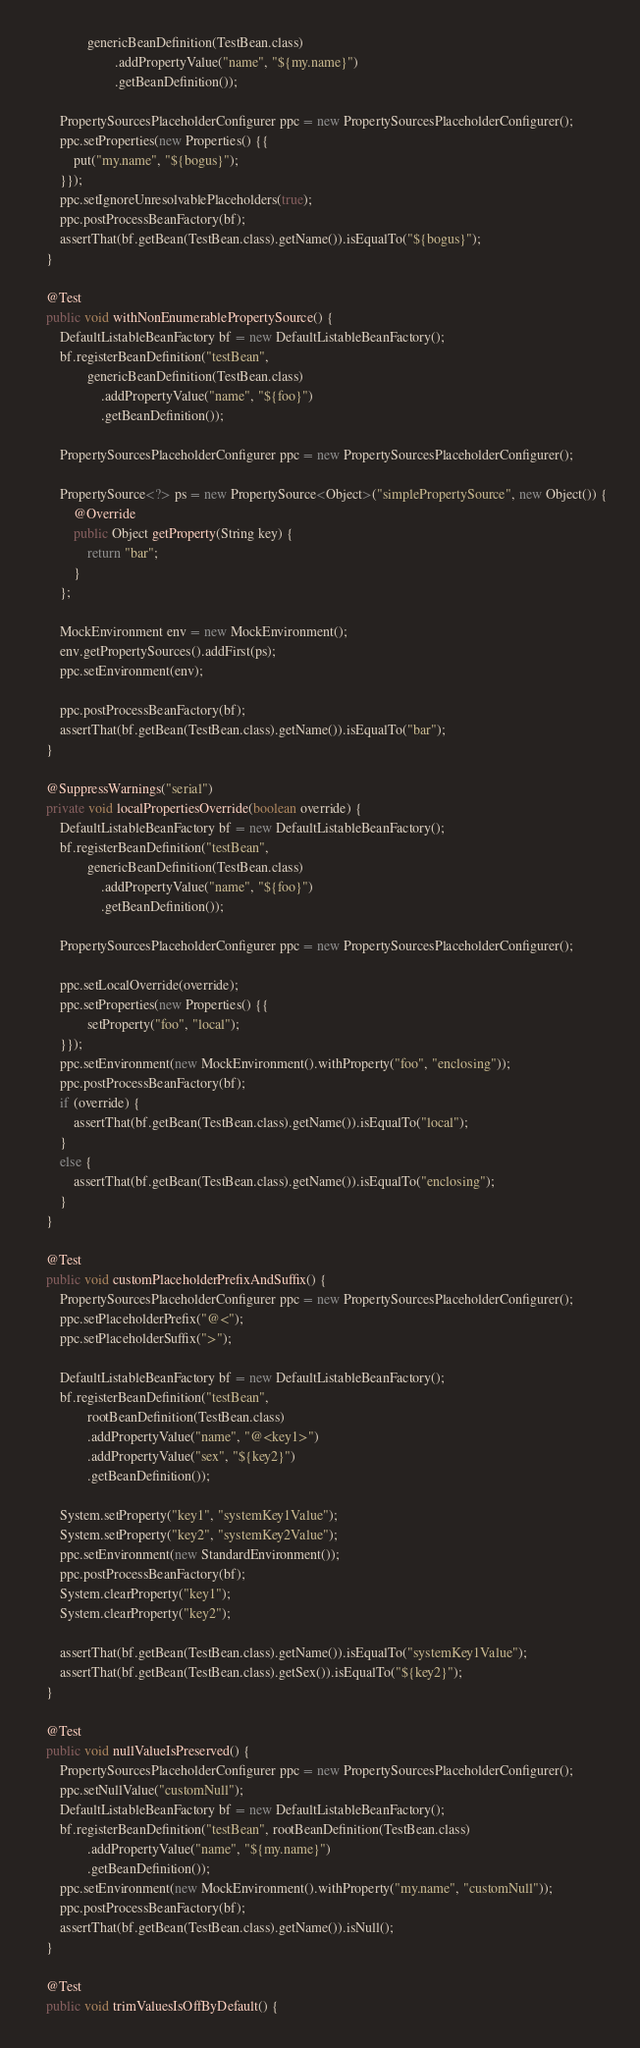Convert code to text. <code><loc_0><loc_0><loc_500><loc_500><_Java_>				genericBeanDefinition(TestBean.class)
						.addPropertyValue("name", "${my.name}")
						.getBeanDefinition());

		PropertySourcesPlaceholderConfigurer ppc = new PropertySourcesPlaceholderConfigurer();
		ppc.setProperties(new Properties() {{
			put("my.name", "${bogus}");
		}});
		ppc.setIgnoreUnresolvablePlaceholders(true);
		ppc.postProcessBeanFactory(bf);
		assertThat(bf.getBean(TestBean.class).getName()).isEqualTo("${bogus}");
	}

	@Test
	public void withNonEnumerablePropertySource() {
		DefaultListableBeanFactory bf = new DefaultListableBeanFactory();
		bf.registerBeanDefinition("testBean",
				genericBeanDefinition(TestBean.class)
					.addPropertyValue("name", "${foo}")
					.getBeanDefinition());

		PropertySourcesPlaceholderConfigurer ppc = new PropertySourcesPlaceholderConfigurer();

		PropertySource<?> ps = new PropertySource<Object>("simplePropertySource", new Object()) {
			@Override
			public Object getProperty(String key) {
				return "bar";
			}
		};

		MockEnvironment env = new MockEnvironment();
		env.getPropertySources().addFirst(ps);
		ppc.setEnvironment(env);

		ppc.postProcessBeanFactory(bf);
		assertThat(bf.getBean(TestBean.class).getName()).isEqualTo("bar");
	}

	@SuppressWarnings("serial")
	private void localPropertiesOverride(boolean override) {
		DefaultListableBeanFactory bf = new DefaultListableBeanFactory();
		bf.registerBeanDefinition("testBean",
				genericBeanDefinition(TestBean.class)
					.addPropertyValue("name", "${foo}")
					.getBeanDefinition());

		PropertySourcesPlaceholderConfigurer ppc = new PropertySourcesPlaceholderConfigurer();

		ppc.setLocalOverride(override);
		ppc.setProperties(new Properties() {{
				setProperty("foo", "local");
		}});
		ppc.setEnvironment(new MockEnvironment().withProperty("foo", "enclosing"));
		ppc.postProcessBeanFactory(bf);
		if (override) {
			assertThat(bf.getBean(TestBean.class).getName()).isEqualTo("local");
		}
		else {
			assertThat(bf.getBean(TestBean.class).getName()).isEqualTo("enclosing");
		}
	}

	@Test
	public void customPlaceholderPrefixAndSuffix() {
		PropertySourcesPlaceholderConfigurer ppc = new PropertySourcesPlaceholderConfigurer();
		ppc.setPlaceholderPrefix("@<");
		ppc.setPlaceholderSuffix(">");

		DefaultListableBeanFactory bf = new DefaultListableBeanFactory();
		bf.registerBeanDefinition("testBean",
				rootBeanDefinition(TestBean.class)
				.addPropertyValue("name", "@<key1>")
				.addPropertyValue("sex", "${key2}")
				.getBeanDefinition());

		System.setProperty("key1", "systemKey1Value");
		System.setProperty("key2", "systemKey2Value");
		ppc.setEnvironment(new StandardEnvironment());
		ppc.postProcessBeanFactory(bf);
		System.clearProperty("key1");
		System.clearProperty("key2");

		assertThat(bf.getBean(TestBean.class).getName()).isEqualTo("systemKey1Value");
		assertThat(bf.getBean(TestBean.class).getSex()).isEqualTo("${key2}");
	}

	@Test
	public void nullValueIsPreserved() {
		PropertySourcesPlaceholderConfigurer ppc = new PropertySourcesPlaceholderConfigurer();
		ppc.setNullValue("customNull");
		DefaultListableBeanFactory bf = new DefaultListableBeanFactory();
		bf.registerBeanDefinition("testBean", rootBeanDefinition(TestBean.class)
				.addPropertyValue("name", "${my.name}")
				.getBeanDefinition());
		ppc.setEnvironment(new MockEnvironment().withProperty("my.name", "customNull"));
		ppc.postProcessBeanFactory(bf);
		assertThat(bf.getBean(TestBean.class).getName()).isNull();
	}

	@Test
	public void trimValuesIsOffByDefault() {</code> 